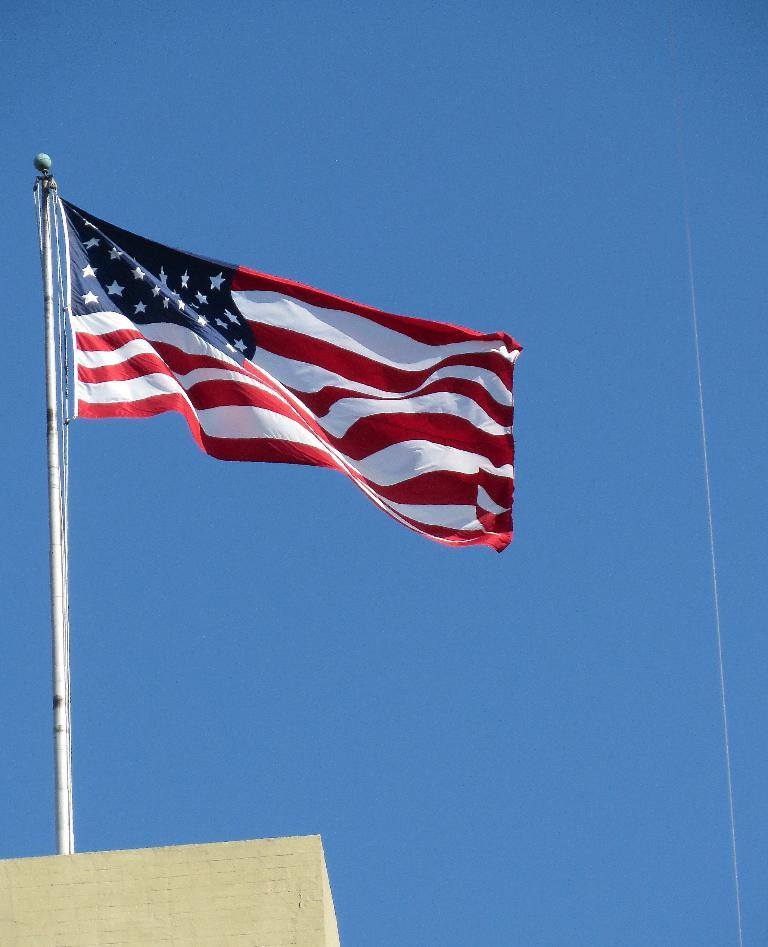What is located on the left side of the image? There is a flag on the left side of the image. What is the flag attached to? The flag is attached to a pole. What can be seen in the bottom left corner of the image? There is a wall visible in the bottom left corner of the image. What is visible in the background of the image? The sky is visible in the background of the image. What type of ink can be seen dripping from the beetle in the image? There is no beetle or ink present in the image. 